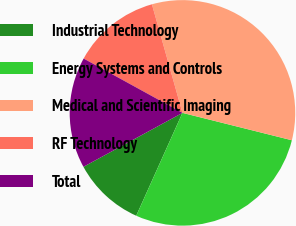<chart> <loc_0><loc_0><loc_500><loc_500><pie_chart><fcel>Industrial Technology<fcel>Energy Systems and Controls<fcel>Medical and Scientific Imaging<fcel>RF Technology<fcel>Total<nl><fcel>10.34%<fcel>27.82%<fcel>33.27%<fcel>12.64%<fcel>15.94%<nl></chart> 